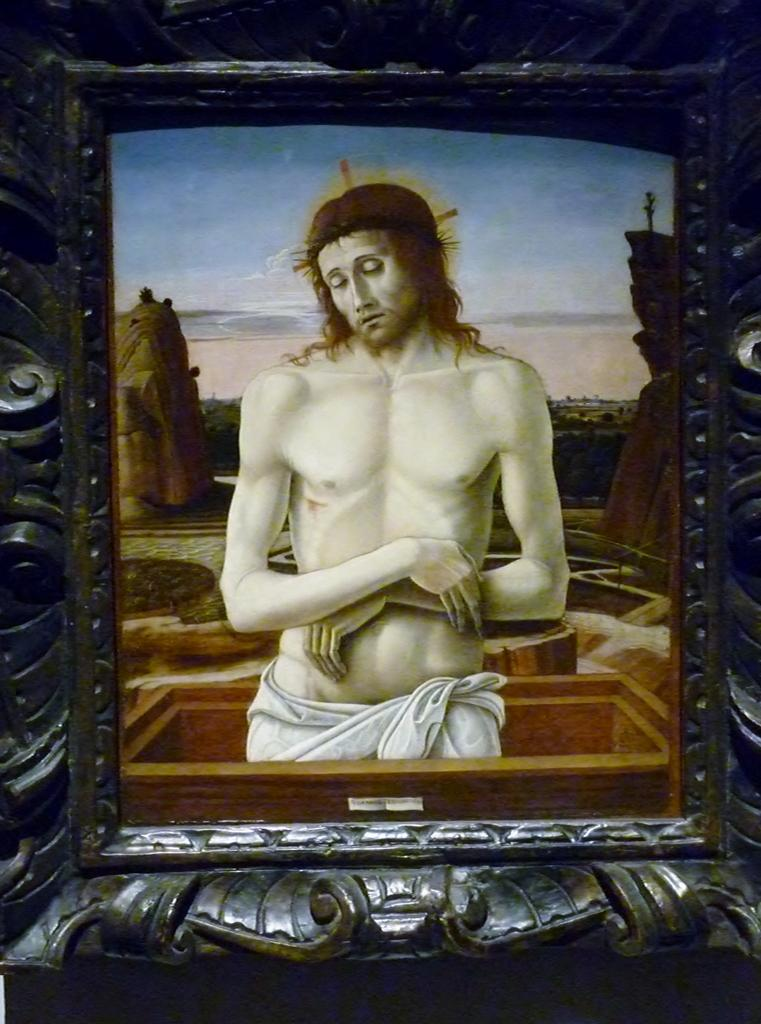What is the main subject of the image? There is a painting in the image. What is the person in the painting doing? The painting depicts a person standing in a box. What type of landscape is visible behind the person in the painting? There are rocks visible behind the person in the painting. What can be seen in the background of the image? The sky is visible in the image. What type of straw is being used to support the person in the painting? There is no straw present in the painting; the person is standing in a box. 